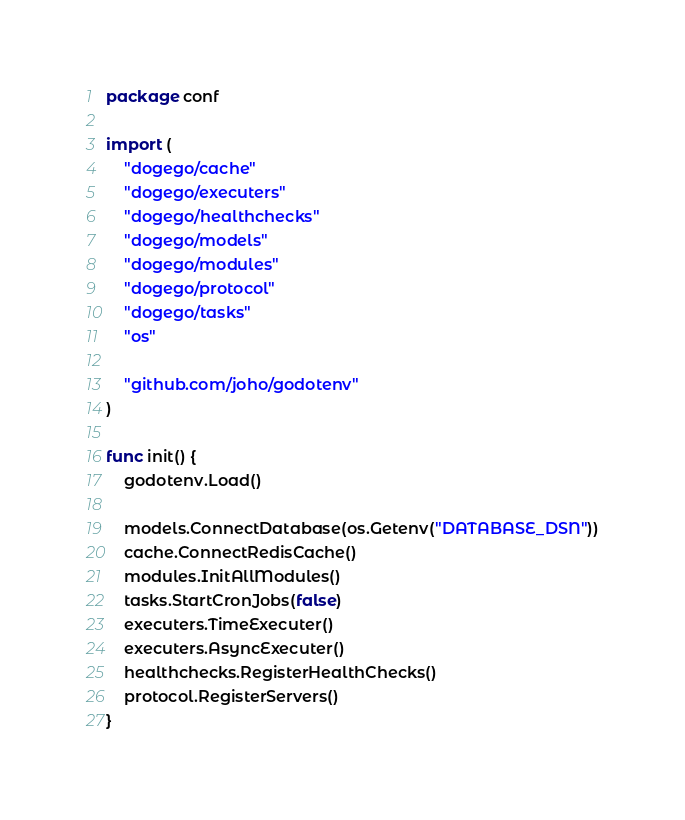<code> <loc_0><loc_0><loc_500><loc_500><_Go_>package conf

import (
	"dogego/cache"
	"dogego/executers"
	"dogego/healthchecks"
	"dogego/models"
	"dogego/modules"
	"dogego/protocol"
	"dogego/tasks"
	"os"

	"github.com/joho/godotenv"
)

func init() {
	godotenv.Load()

	models.ConnectDatabase(os.Getenv("DATABASE_DSN"))
	cache.ConnectRedisCache()
	modules.InitAllModules()
	tasks.StartCronJobs(false)
	executers.TimeExecuter()
	executers.AsyncExecuter()
	healthchecks.RegisterHealthChecks()
	protocol.RegisterServers()
}
</code> 